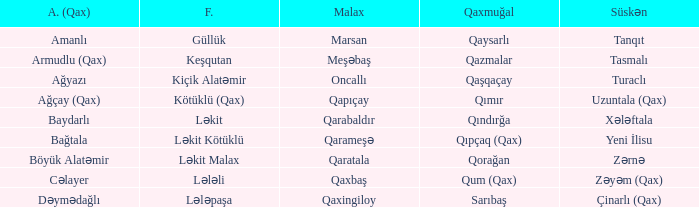What is the Qaxmuğal village with a Malax village meşəbaş? Qazmalar. 